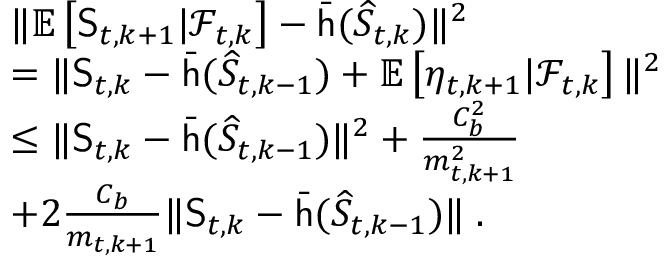<formula> <loc_0><loc_0><loc_500><loc_500>\begin{array} { r l } & { \| \mathbb { E } \left [ S _ { t , k + 1 } | \mathcal { F } _ { t , k } \right ] - \bar { h } ( \widehat { S } _ { t , k } ) \| ^ { 2 } } \\ & { = \| S _ { t , k } - \bar { h } ( \widehat { S } _ { t , k - 1 } ) + \mathbb { E } \left [ \eta _ { t , k + 1 } | \mathcal { F } _ { t , k } \right ] \| ^ { 2 } } \\ & { \leq \| S _ { t , k } - \bar { h } ( \widehat { S } _ { t , k - 1 } ) \| ^ { 2 } + \frac { C _ { b } ^ { 2 } } { m _ { t , k + 1 } ^ { 2 } } } \\ & { + 2 \frac { C _ { b } } { m _ { t , k + 1 } } \| S _ { t , k } - \bar { h } ( \widehat { S } _ { t , k - 1 } ) \| \, . } \end{array}</formula> 